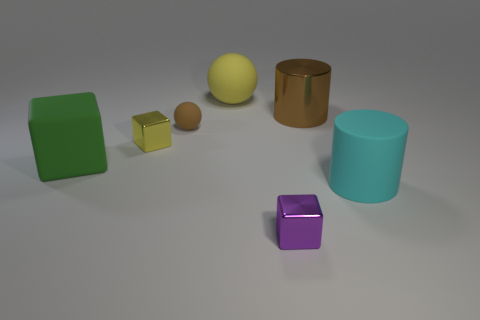There is a green thing left of the big matte object behind the small yellow shiny cube behind the cyan rubber cylinder; what is its shape?
Your answer should be compact. Cube. What material is the small object that is in front of the green matte object?
Your answer should be very brief. Metal. What color is the rubber object that is the same size as the purple cube?
Give a very brief answer. Brown. What number of other objects are the same shape as the tiny purple metallic object?
Your answer should be very brief. 2. Does the brown shiny cylinder have the same size as the yellow shiny thing?
Give a very brief answer. No. Is the number of tiny brown objects that are in front of the yellow shiny block greater than the number of large rubber things in front of the cyan object?
Give a very brief answer. No. How many other objects are the same size as the brown shiny cylinder?
Your answer should be compact. 3. There is a tiny object in front of the big cyan cylinder; is it the same color as the matte cube?
Keep it short and to the point. No. Is the number of tiny brown rubber objects that are on the left side of the yellow metallic cube greater than the number of small blue cubes?
Offer a terse response. No. Is there any other thing that is the same color as the matte block?
Keep it short and to the point. No. 